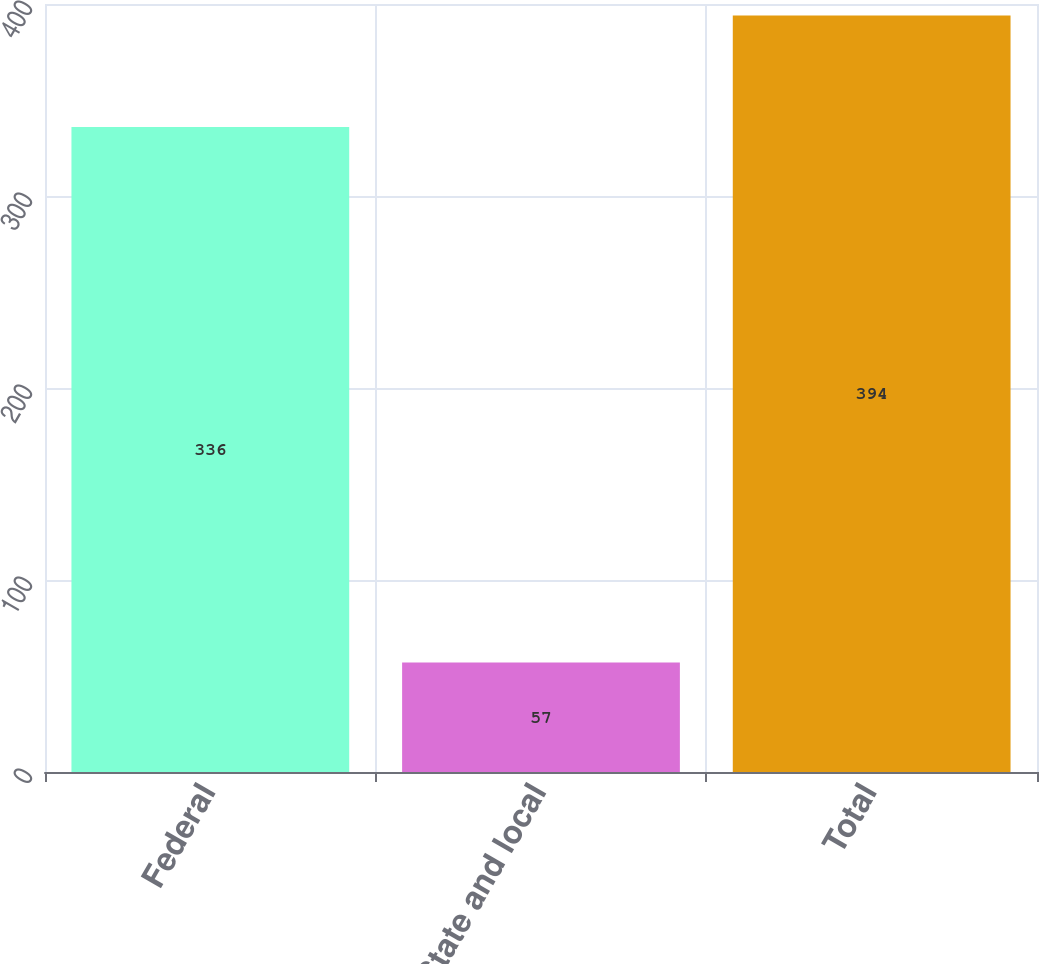Convert chart. <chart><loc_0><loc_0><loc_500><loc_500><bar_chart><fcel>Federal<fcel>State and local<fcel>Total<nl><fcel>336<fcel>57<fcel>394<nl></chart> 